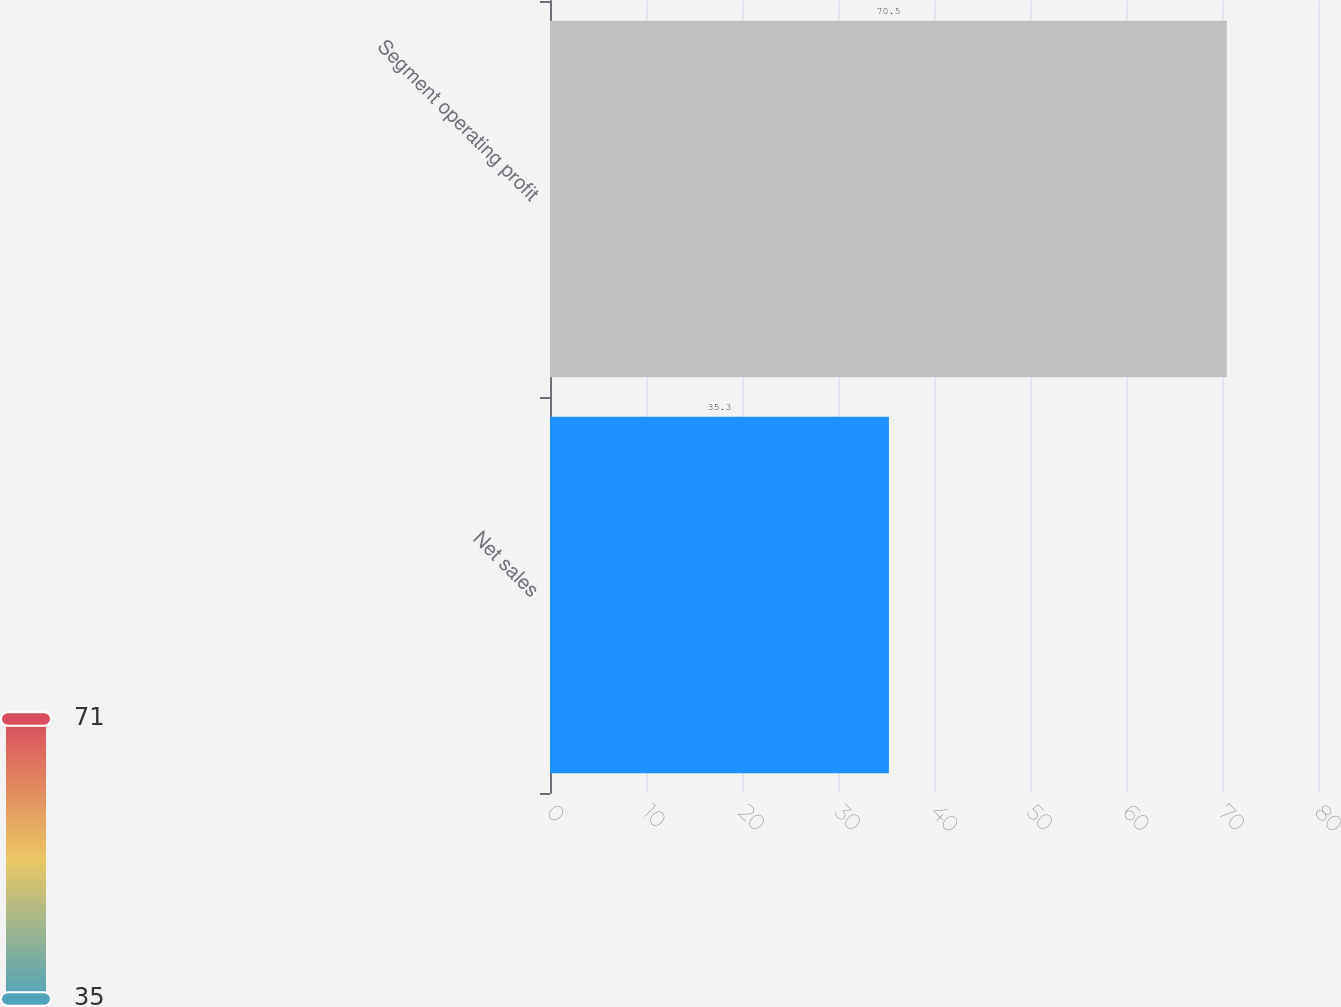Convert chart to OTSL. <chart><loc_0><loc_0><loc_500><loc_500><bar_chart><fcel>Net sales<fcel>Segment operating profit<nl><fcel>35.3<fcel>70.5<nl></chart> 